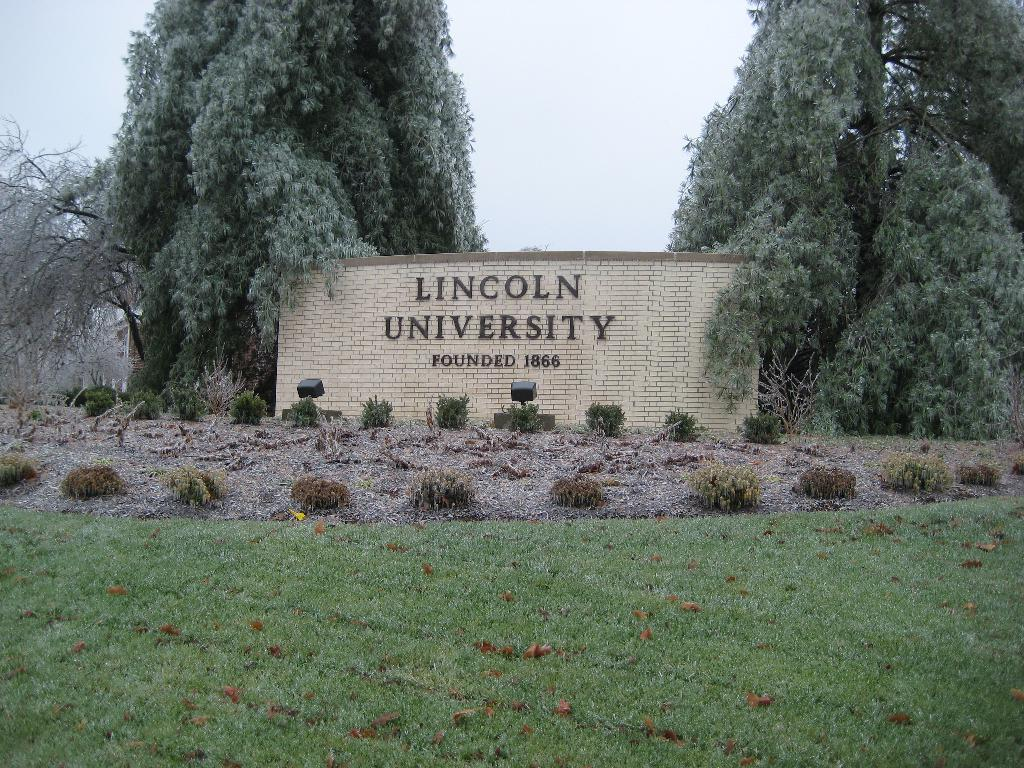What type of vegetation can be seen in the image? There is grass and plants in the image. What other objects are present in the image? There are focus lights, trees, and a wall with numbers in the image. What is written on the wall? There is a university name on the wall. What can be seen in the background of the image? The sky is visible in the background of the image. What verse can be seen written on the grass in the image? There is no verse written on the grass in the image; it is a natural landscape with no text or writing. 